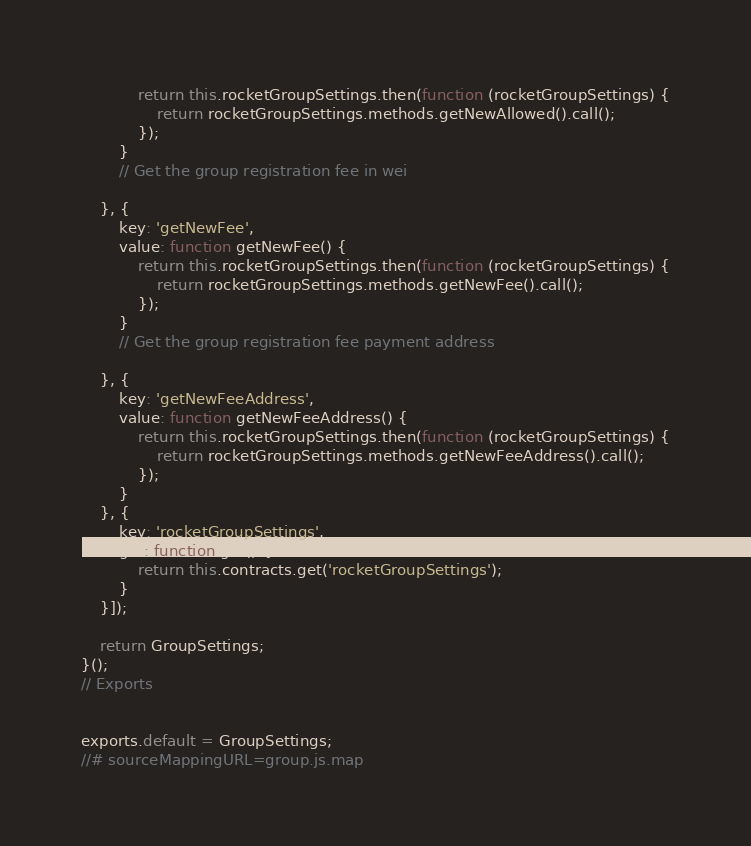Convert code to text. <code><loc_0><loc_0><loc_500><loc_500><_JavaScript_>            return this.rocketGroupSettings.then(function (rocketGroupSettings) {
                return rocketGroupSettings.methods.getNewAllowed().call();
            });
        }
        // Get the group registration fee in wei

    }, {
        key: 'getNewFee',
        value: function getNewFee() {
            return this.rocketGroupSettings.then(function (rocketGroupSettings) {
                return rocketGroupSettings.methods.getNewFee().call();
            });
        }
        // Get the group registration fee payment address

    }, {
        key: 'getNewFeeAddress',
        value: function getNewFeeAddress() {
            return this.rocketGroupSettings.then(function (rocketGroupSettings) {
                return rocketGroupSettings.methods.getNewFeeAddress().call();
            });
        }
    }, {
        key: 'rocketGroupSettings',
        get: function get() {
            return this.contracts.get('rocketGroupSettings');
        }
    }]);

    return GroupSettings;
}();
// Exports


exports.default = GroupSettings;
//# sourceMappingURL=group.js.map</code> 